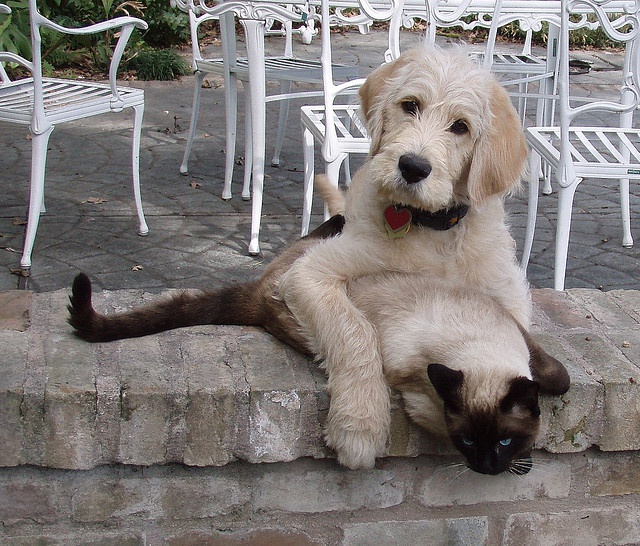Describe the objects in this image and their specific colors. I can see dog in black, darkgray, and gray tones, cat in black, darkgray, gray, and lightgray tones, chair in black, lightgray, darkgray, and gray tones, chair in black, lightgray, gray, and darkgray tones, and chair in black, lightgray, darkgray, and gray tones in this image. 